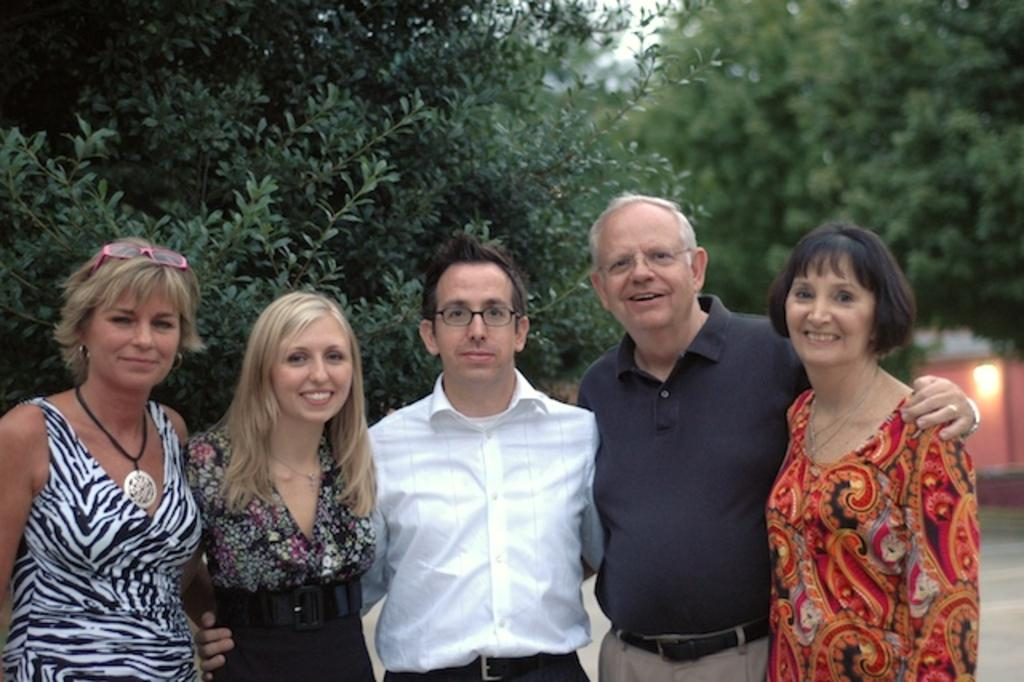How many people are in the image? There is a group of people in the image. What are the people in the image doing? The people are standing and smiling. What can be seen in the background of the image? There is a building, trees, and the sky visible in the background of the image. Can you describe the lighting in the image? There is a light on the wall in the image. What type of drum can be heard playing in the background of the image? There is no drum or sound present in the image; it only shows a group of people standing and smiling, with a building, trees, and a light on the wall in the background. 